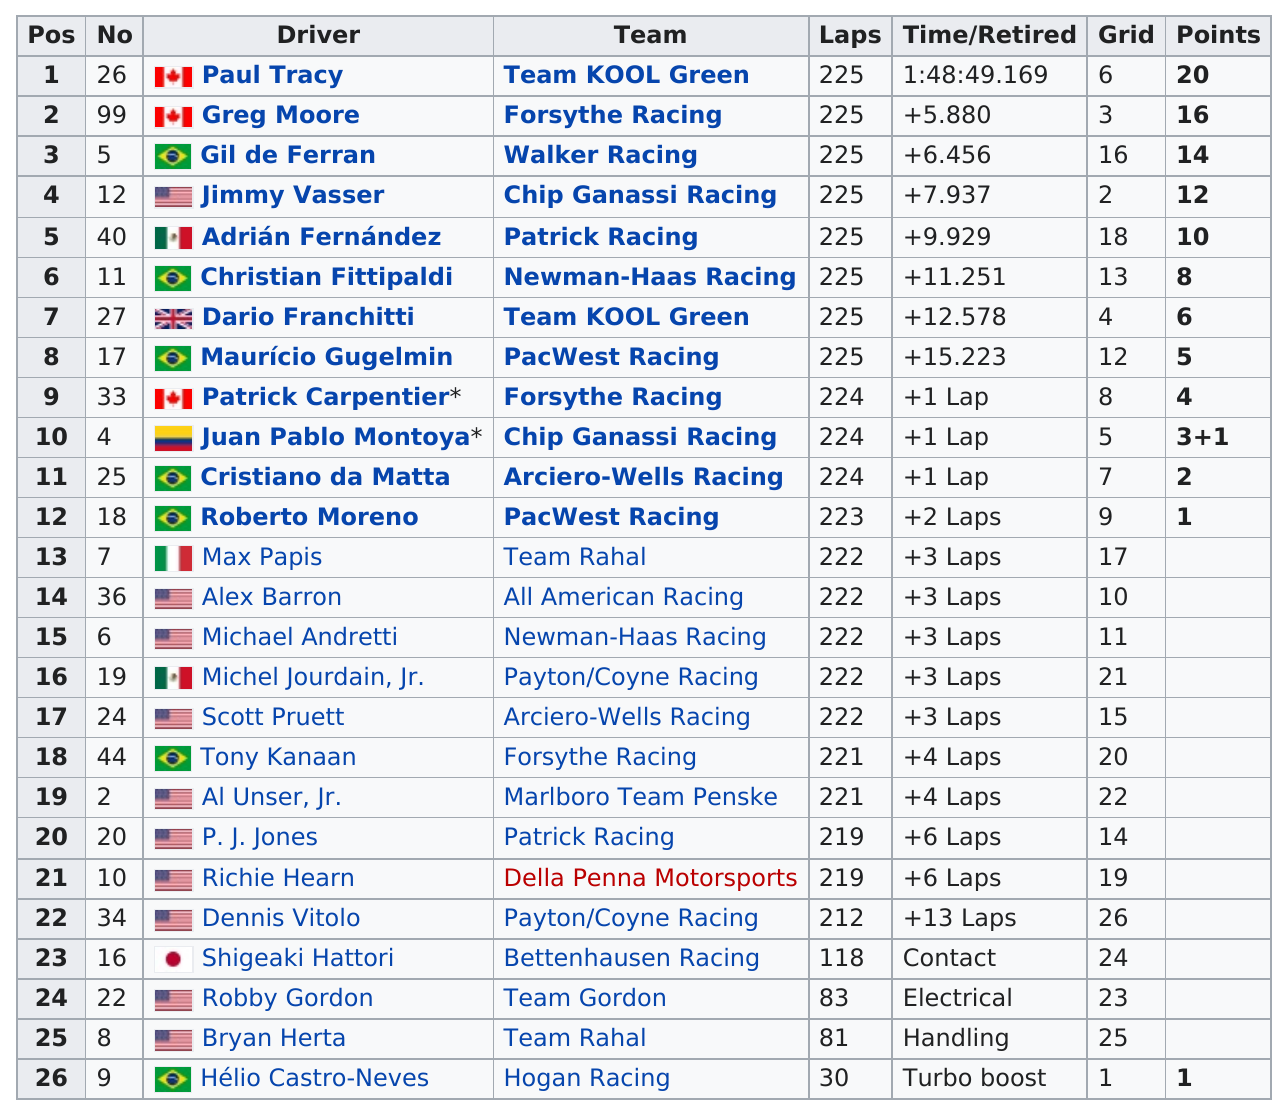Specify some key components in this picture. Greg Moore, a driver from the same racing team as Patrick Carpentier, who placed ninth in a previous race, is a notable individual in the sport. Patrick Carpentier earned a total of four points during the 1999 Miller Lite 225. The person who placed first in this race is Paul Tracy. The top 3 finishers of the 1999 Miller Lite 225 earned a combined total of 50 points. The total number of drivers on the Kool Green team is two. 